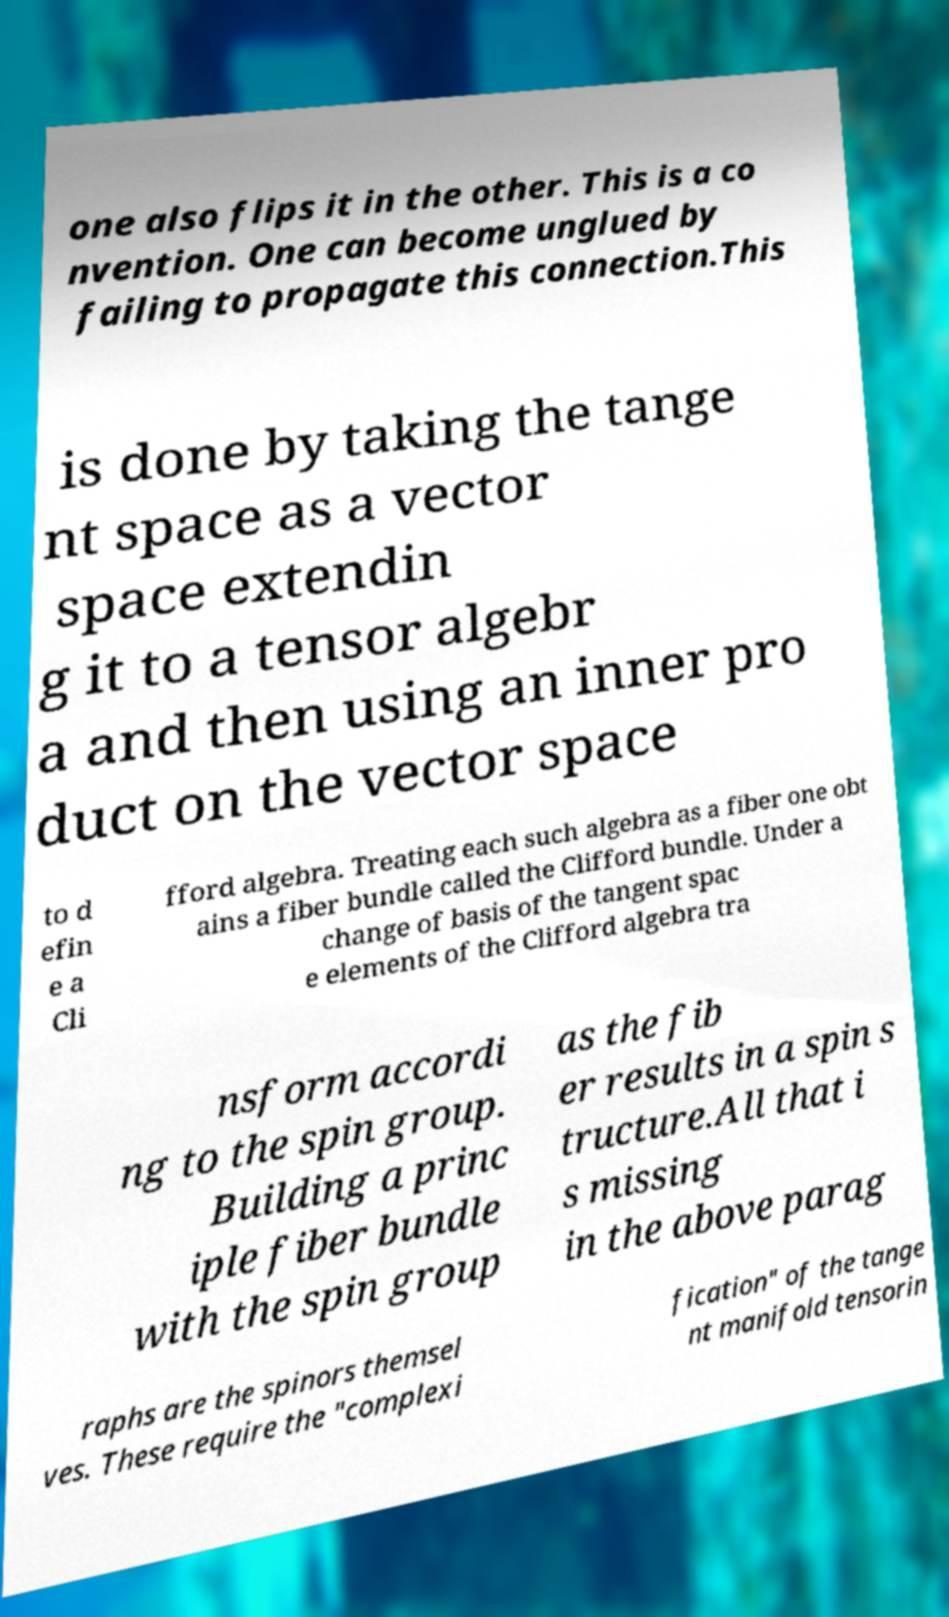What messages or text are displayed in this image? I need them in a readable, typed format. one also flips it in the other. This is a co nvention. One can become unglued by failing to propagate this connection.This is done by taking the tange nt space as a vector space extendin g it to a tensor algebr a and then using an inner pro duct on the vector space to d efin e a Cli fford algebra. Treating each such algebra as a fiber one obt ains a fiber bundle called the Clifford bundle. Under a change of basis of the tangent spac e elements of the Clifford algebra tra nsform accordi ng to the spin group. Building a princ iple fiber bundle with the spin group as the fib er results in a spin s tructure.All that i s missing in the above parag raphs are the spinors themsel ves. These require the "complexi fication" of the tange nt manifold tensorin 